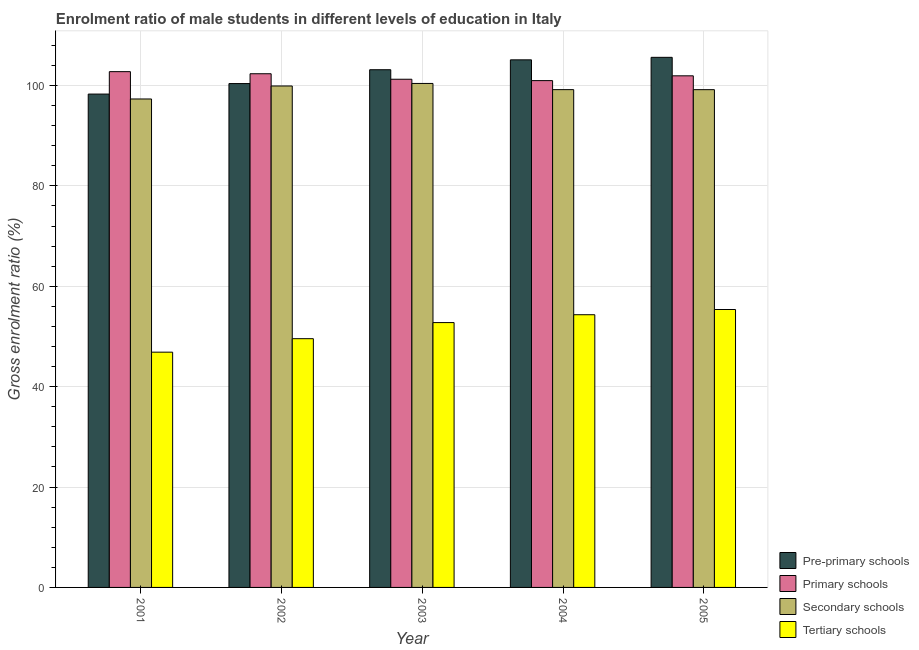How many groups of bars are there?
Provide a succinct answer. 5. How many bars are there on the 1st tick from the left?
Offer a very short reply. 4. What is the label of the 1st group of bars from the left?
Offer a terse response. 2001. What is the gross enrolment ratio(female) in primary schools in 2001?
Give a very brief answer. 102.76. Across all years, what is the maximum gross enrolment ratio(female) in tertiary schools?
Give a very brief answer. 55.37. Across all years, what is the minimum gross enrolment ratio(female) in secondary schools?
Give a very brief answer. 97.32. In which year was the gross enrolment ratio(female) in secondary schools maximum?
Your answer should be compact. 2003. What is the total gross enrolment ratio(female) in primary schools in the graph?
Your answer should be very brief. 509.27. What is the difference between the gross enrolment ratio(female) in pre-primary schools in 2002 and that in 2004?
Keep it short and to the point. -4.73. What is the difference between the gross enrolment ratio(female) in pre-primary schools in 2004 and the gross enrolment ratio(female) in primary schools in 2002?
Your response must be concise. 4.73. What is the average gross enrolment ratio(female) in primary schools per year?
Your answer should be very brief. 101.85. In how many years, is the gross enrolment ratio(female) in secondary schools greater than 64 %?
Provide a succinct answer. 5. What is the ratio of the gross enrolment ratio(female) in primary schools in 2001 to that in 2004?
Make the answer very short. 1.02. Is the gross enrolment ratio(female) in secondary schools in 2003 less than that in 2004?
Provide a short and direct response. No. Is the difference between the gross enrolment ratio(female) in tertiary schools in 2003 and 2004 greater than the difference between the gross enrolment ratio(female) in pre-primary schools in 2003 and 2004?
Provide a succinct answer. No. What is the difference between the highest and the second highest gross enrolment ratio(female) in primary schools?
Your answer should be compact. 0.42. What is the difference between the highest and the lowest gross enrolment ratio(female) in tertiary schools?
Give a very brief answer. 8.5. Is the sum of the gross enrolment ratio(female) in pre-primary schools in 2003 and 2004 greater than the maximum gross enrolment ratio(female) in primary schools across all years?
Ensure brevity in your answer.  Yes. What does the 1st bar from the left in 2003 represents?
Ensure brevity in your answer.  Pre-primary schools. What does the 3rd bar from the right in 2003 represents?
Ensure brevity in your answer.  Primary schools. Is it the case that in every year, the sum of the gross enrolment ratio(female) in pre-primary schools and gross enrolment ratio(female) in primary schools is greater than the gross enrolment ratio(female) in secondary schools?
Give a very brief answer. Yes. How many years are there in the graph?
Provide a short and direct response. 5. Does the graph contain grids?
Your answer should be very brief. Yes. How many legend labels are there?
Ensure brevity in your answer.  4. What is the title of the graph?
Your response must be concise. Enrolment ratio of male students in different levels of education in Italy. What is the label or title of the Y-axis?
Your answer should be compact. Gross enrolment ratio (%). What is the Gross enrolment ratio (%) of Pre-primary schools in 2001?
Your response must be concise. 98.29. What is the Gross enrolment ratio (%) of Primary schools in 2001?
Offer a very short reply. 102.76. What is the Gross enrolment ratio (%) in Secondary schools in 2001?
Make the answer very short. 97.32. What is the Gross enrolment ratio (%) of Tertiary schools in 2001?
Keep it short and to the point. 46.87. What is the Gross enrolment ratio (%) in Pre-primary schools in 2002?
Your response must be concise. 100.39. What is the Gross enrolment ratio (%) in Primary schools in 2002?
Provide a succinct answer. 102.34. What is the Gross enrolment ratio (%) in Secondary schools in 2002?
Offer a very short reply. 99.91. What is the Gross enrolment ratio (%) of Tertiary schools in 2002?
Ensure brevity in your answer.  49.56. What is the Gross enrolment ratio (%) in Pre-primary schools in 2003?
Offer a very short reply. 103.15. What is the Gross enrolment ratio (%) in Primary schools in 2003?
Offer a very short reply. 101.25. What is the Gross enrolment ratio (%) of Secondary schools in 2003?
Give a very brief answer. 100.41. What is the Gross enrolment ratio (%) of Tertiary schools in 2003?
Provide a succinct answer. 52.77. What is the Gross enrolment ratio (%) of Pre-primary schools in 2004?
Your answer should be compact. 105.12. What is the Gross enrolment ratio (%) in Primary schools in 2004?
Keep it short and to the point. 100.98. What is the Gross enrolment ratio (%) of Secondary schools in 2004?
Your response must be concise. 99.18. What is the Gross enrolment ratio (%) in Tertiary schools in 2004?
Your answer should be very brief. 54.33. What is the Gross enrolment ratio (%) in Pre-primary schools in 2005?
Offer a very short reply. 105.62. What is the Gross enrolment ratio (%) in Primary schools in 2005?
Offer a terse response. 101.93. What is the Gross enrolment ratio (%) in Secondary schools in 2005?
Offer a very short reply. 99.17. What is the Gross enrolment ratio (%) in Tertiary schools in 2005?
Offer a very short reply. 55.37. Across all years, what is the maximum Gross enrolment ratio (%) of Pre-primary schools?
Keep it short and to the point. 105.62. Across all years, what is the maximum Gross enrolment ratio (%) in Primary schools?
Your response must be concise. 102.76. Across all years, what is the maximum Gross enrolment ratio (%) in Secondary schools?
Ensure brevity in your answer.  100.41. Across all years, what is the maximum Gross enrolment ratio (%) in Tertiary schools?
Provide a succinct answer. 55.37. Across all years, what is the minimum Gross enrolment ratio (%) in Pre-primary schools?
Provide a short and direct response. 98.29. Across all years, what is the minimum Gross enrolment ratio (%) of Primary schools?
Ensure brevity in your answer.  100.98. Across all years, what is the minimum Gross enrolment ratio (%) in Secondary schools?
Provide a succinct answer. 97.32. Across all years, what is the minimum Gross enrolment ratio (%) of Tertiary schools?
Your response must be concise. 46.87. What is the total Gross enrolment ratio (%) in Pre-primary schools in the graph?
Your answer should be compact. 512.56. What is the total Gross enrolment ratio (%) of Primary schools in the graph?
Offer a terse response. 509.27. What is the total Gross enrolment ratio (%) of Secondary schools in the graph?
Your answer should be compact. 495.99. What is the total Gross enrolment ratio (%) of Tertiary schools in the graph?
Keep it short and to the point. 258.9. What is the difference between the Gross enrolment ratio (%) in Pre-primary schools in 2001 and that in 2002?
Offer a very short reply. -2.09. What is the difference between the Gross enrolment ratio (%) in Primary schools in 2001 and that in 2002?
Ensure brevity in your answer.  0.42. What is the difference between the Gross enrolment ratio (%) in Secondary schools in 2001 and that in 2002?
Ensure brevity in your answer.  -2.59. What is the difference between the Gross enrolment ratio (%) of Tertiary schools in 2001 and that in 2002?
Ensure brevity in your answer.  -2.69. What is the difference between the Gross enrolment ratio (%) in Pre-primary schools in 2001 and that in 2003?
Your answer should be compact. -4.85. What is the difference between the Gross enrolment ratio (%) of Primary schools in 2001 and that in 2003?
Offer a very short reply. 1.51. What is the difference between the Gross enrolment ratio (%) of Secondary schools in 2001 and that in 2003?
Provide a succinct answer. -3.09. What is the difference between the Gross enrolment ratio (%) of Tertiary schools in 2001 and that in 2003?
Your response must be concise. -5.89. What is the difference between the Gross enrolment ratio (%) in Pre-primary schools in 2001 and that in 2004?
Ensure brevity in your answer.  -6.82. What is the difference between the Gross enrolment ratio (%) in Primary schools in 2001 and that in 2004?
Provide a succinct answer. 1.79. What is the difference between the Gross enrolment ratio (%) in Secondary schools in 2001 and that in 2004?
Your response must be concise. -1.86. What is the difference between the Gross enrolment ratio (%) in Tertiary schools in 2001 and that in 2004?
Keep it short and to the point. -7.46. What is the difference between the Gross enrolment ratio (%) of Pre-primary schools in 2001 and that in 2005?
Your answer should be very brief. -7.32. What is the difference between the Gross enrolment ratio (%) in Primary schools in 2001 and that in 2005?
Your answer should be compact. 0.83. What is the difference between the Gross enrolment ratio (%) of Secondary schools in 2001 and that in 2005?
Offer a very short reply. -1.85. What is the difference between the Gross enrolment ratio (%) of Tertiary schools in 2001 and that in 2005?
Ensure brevity in your answer.  -8.5. What is the difference between the Gross enrolment ratio (%) in Pre-primary schools in 2002 and that in 2003?
Your answer should be compact. -2.76. What is the difference between the Gross enrolment ratio (%) in Primary schools in 2002 and that in 2003?
Your answer should be very brief. 1.1. What is the difference between the Gross enrolment ratio (%) in Secondary schools in 2002 and that in 2003?
Your answer should be very brief. -0.5. What is the difference between the Gross enrolment ratio (%) in Tertiary schools in 2002 and that in 2003?
Ensure brevity in your answer.  -3.21. What is the difference between the Gross enrolment ratio (%) in Pre-primary schools in 2002 and that in 2004?
Provide a short and direct response. -4.73. What is the difference between the Gross enrolment ratio (%) in Primary schools in 2002 and that in 2004?
Provide a succinct answer. 1.37. What is the difference between the Gross enrolment ratio (%) in Secondary schools in 2002 and that in 2004?
Offer a very short reply. 0.73. What is the difference between the Gross enrolment ratio (%) in Tertiary schools in 2002 and that in 2004?
Provide a succinct answer. -4.77. What is the difference between the Gross enrolment ratio (%) of Pre-primary schools in 2002 and that in 2005?
Your answer should be very brief. -5.23. What is the difference between the Gross enrolment ratio (%) in Primary schools in 2002 and that in 2005?
Offer a terse response. 0.41. What is the difference between the Gross enrolment ratio (%) in Secondary schools in 2002 and that in 2005?
Provide a succinct answer. 0.73. What is the difference between the Gross enrolment ratio (%) in Tertiary schools in 2002 and that in 2005?
Make the answer very short. -5.81. What is the difference between the Gross enrolment ratio (%) of Pre-primary schools in 2003 and that in 2004?
Offer a terse response. -1.97. What is the difference between the Gross enrolment ratio (%) of Primary schools in 2003 and that in 2004?
Provide a succinct answer. 0.27. What is the difference between the Gross enrolment ratio (%) of Secondary schools in 2003 and that in 2004?
Your answer should be very brief. 1.23. What is the difference between the Gross enrolment ratio (%) of Tertiary schools in 2003 and that in 2004?
Offer a very short reply. -1.56. What is the difference between the Gross enrolment ratio (%) in Pre-primary schools in 2003 and that in 2005?
Offer a very short reply. -2.47. What is the difference between the Gross enrolment ratio (%) in Primary schools in 2003 and that in 2005?
Offer a terse response. -0.68. What is the difference between the Gross enrolment ratio (%) of Secondary schools in 2003 and that in 2005?
Your answer should be very brief. 1.24. What is the difference between the Gross enrolment ratio (%) in Tertiary schools in 2003 and that in 2005?
Ensure brevity in your answer.  -2.6. What is the difference between the Gross enrolment ratio (%) of Pre-primary schools in 2004 and that in 2005?
Your answer should be compact. -0.5. What is the difference between the Gross enrolment ratio (%) of Primary schools in 2004 and that in 2005?
Provide a succinct answer. -0.96. What is the difference between the Gross enrolment ratio (%) of Secondary schools in 2004 and that in 2005?
Give a very brief answer. 0.01. What is the difference between the Gross enrolment ratio (%) of Tertiary schools in 2004 and that in 2005?
Ensure brevity in your answer.  -1.04. What is the difference between the Gross enrolment ratio (%) of Pre-primary schools in 2001 and the Gross enrolment ratio (%) of Primary schools in 2002?
Offer a terse response. -4.05. What is the difference between the Gross enrolment ratio (%) of Pre-primary schools in 2001 and the Gross enrolment ratio (%) of Secondary schools in 2002?
Offer a very short reply. -1.61. What is the difference between the Gross enrolment ratio (%) of Pre-primary schools in 2001 and the Gross enrolment ratio (%) of Tertiary schools in 2002?
Provide a short and direct response. 48.73. What is the difference between the Gross enrolment ratio (%) of Primary schools in 2001 and the Gross enrolment ratio (%) of Secondary schools in 2002?
Your answer should be compact. 2.86. What is the difference between the Gross enrolment ratio (%) of Primary schools in 2001 and the Gross enrolment ratio (%) of Tertiary schools in 2002?
Your answer should be very brief. 53.2. What is the difference between the Gross enrolment ratio (%) of Secondary schools in 2001 and the Gross enrolment ratio (%) of Tertiary schools in 2002?
Provide a short and direct response. 47.76. What is the difference between the Gross enrolment ratio (%) in Pre-primary schools in 2001 and the Gross enrolment ratio (%) in Primary schools in 2003?
Ensure brevity in your answer.  -2.96. What is the difference between the Gross enrolment ratio (%) in Pre-primary schools in 2001 and the Gross enrolment ratio (%) in Secondary schools in 2003?
Offer a very short reply. -2.12. What is the difference between the Gross enrolment ratio (%) in Pre-primary schools in 2001 and the Gross enrolment ratio (%) in Tertiary schools in 2003?
Make the answer very short. 45.53. What is the difference between the Gross enrolment ratio (%) of Primary schools in 2001 and the Gross enrolment ratio (%) of Secondary schools in 2003?
Keep it short and to the point. 2.35. What is the difference between the Gross enrolment ratio (%) of Primary schools in 2001 and the Gross enrolment ratio (%) of Tertiary schools in 2003?
Your answer should be compact. 50. What is the difference between the Gross enrolment ratio (%) of Secondary schools in 2001 and the Gross enrolment ratio (%) of Tertiary schools in 2003?
Offer a very short reply. 44.55. What is the difference between the Gross enrolment ratio (%) of Pre-primary schools in 2001 and the Gross enrolment ratio (%) of Primary schools in 2004?
Keep it short and to the point. -2.68. What is the difference between the Gross enrolment ratio (%) of Pre-primary schools in 2001 and the Gross enrolment ratio (%) of Secondary schools in 2004?
Your answer should be very brief. -0.88. What is the difference between the Gross enrolment ratio (%) of Pre-primary schools in 2001 and the Gross enrolment ratio (%) of Tertiary schools in 2004?
Provide a short and direct response. 43.96. What is the difference between the Gross enrolment ratio (%) of Primary schools in 2001 and the Gross enrolment ratio (%) of Secondary schools in 2004?
Your answer should be very brief. 3.59. What is the difference between the Gross enrolment ratio (%) of Primary schools in 2001 and the Gross enrolment ratio (%) of Tertiary schools in 2004?
Provide a succinct answer. 48.43. What is the difference between the Gross enrolment ratio (%) of Secondary schools in 2001 and the Gross enrolment ratio (%) of Tertiary schools in 2004?
Give a very brief answer. 42.99. What is the difference between the Gross enrolment ratio (%) of Pre-primary schools in 2001 and the Gross enrolment ratio (%) of Primary schools in 2005?
Your answer should be very brief. -3.64. What is the difference between the Gross enrolment ratio (%) in Pre-primary schools in 2001 and the Gross enrolment ratio (%) in Secondary schools in 2005?
Offer a very short reply. -0.88. What is the difference between the Gross enrolment ratio (%) in Pre-primary schools in 2001 and the Gross enrolment ratio (%) in Tertiary schools in 2005?
Provide a succinct answer. 42.92. What is the difference between the Gross enrolment ratio (%) of Primary schools in 2001 and the Gross enrolment ratio (%) of Secondary schools in 2005?
Ensure brevity in your answer.  3.59. What is the difference between the Gross enrolment ratio (%) in Primary schools in 2001 and the Gross enrolment ratio (%) in Tertiary schools in 2005?
Offer a terse response. 47.39. What is the difference between the Gross enrolment ratio (%) in Secondary schools in 2001 and the Gross enrolment ratio (%) in Tertiary schools in 2005?
Offer a very short reply. 41.95. What is the difference between the Gross enrolment ratio (%) of Pre-primary schools in 2002 and the Gross enrolment ratio (%) of Primary schools in 2003?
Offer a very short reply. -0.86. What is the difference between the Gross enrolment ratio (%) in Pre-primary schools in 2002 and the Gross enrolment ratio (%) in Secondary schools in 2003?
Provide a succinct answer. -0.02. What is the difference between the Gross enrolment ratio (%) of Pre-primary schools in 2002 and the Gross enrolment ratio (%) of Tertiary schools in 2003?
Provide a succinct answer. 47.62. What is the difference between the Gross enrolment ratio (%) in Primary schools in 2002 and the Gross enrolment ratio (%) in Secondary schools in 2003?
Your answer should be very brief. 1.93. What is the difference between the Gross enrolment ratio (%) of Primary schools in 2002 and the Gross enrolment ratio (%) of Tertiary schools in 2003?
Offer a very short reply. 49.58. What is the difference between the Gross enrolment ratio (%) in Secondary schools in 2002 and the Gross enrolment ratio (%) in Tertiary schools in 2003?
Keep it short and to the point. 47.14. What is the difference between the Gross enrolment ratio (%) of Pre-primary schools in 2002 and the Gross enrolment ratio (%) of Primary schools in 2004?
Give a very brief answer. -0.59. What is the difference between the Gross enrolment ratio (%) in Pre-primary schools in 2002 and the Gross enrolment ratio (%) in Secondary schools in 2004?
Offer a very short reply. 1.21. What is the difference between the Gross enrolment ratio (%) of Pre-primary schools in 2002 and the Gross enrolment ratio (%) of Tertiary schools in 2004?
Keep it short and to the point. 46.06. What is the difference between the Gross enrolment ratio (%) of Primary schools in 2002 and the Gross enrolment ratio (%) of Secondary schools in 2004?
Your response must be concise. 3.17. What is the difference between the Gross enrolment ratio (%) in Primary schools in 2002 and the Gross enrolment ratio (%) in Tertiary schools in 2004?
Your response must be concise. 48.01. What is the difference between the Gross enrolment ratio (%) in Secondary schools in 2002 and the Gross enrolment ratio (%) in Tertiary schools in 2004?
Make the answer very short. 45.57. What is the difference between the Gross enrolment ratio (%) in Pre-primary schools in 2002 and the Gross enrolment ratio (%) in Primary schools in 2005?
Provide a short and direct response. -1.54. What is the difference between the Gross enrolment ratio (%) in Pre-primary schools in 2002 and the Gross enrolment ratio (%) in Secondary schools in 2005?
Ensure brevity in your answer.  1.22. What is the difference between the Gross enrolment ratio (%) of Pre-primary schools in 2002 and the Gross enrolment ratio (%) of Tertiary schools in 2005?
Give a very brief answer. 45.02. What is the difference between the Gross enrolment ratio (%) of Primary schools in 2002 and the Gross enrolment ratio (%) of Secondary schools in 2005?
Provide a succinct answer. 3.17. What is the difference between the Gross enrolment ratio (%) in Primary schools in 2002 and the Gross enrolment ratio (%) in Tertiary schools in 2005?
Offer a terse response. 46.97. What is the difference between the Gross enrolment ratio (%) in Secondary schools in 2002 and the Gross enrolment ratio (%) in Tertiary schools in 2005?
Offer a very short reply. 44.54. What is the difference between the Gross enrolment ratio (%) in Pre-primary schools in 2003 and the Gross enrolment ratio (%) in Primary schools in 2004?
Offer a terse response. 2.17. What is the difference between the Gross enrolment ratio (%) in Pre-primary schools in 2003 and the Gross enrolment ratio (%) in Secondary schools in 2004?
Your answer should be compact. 3.97. What is the difference between the Gross enrolment ratio (%) in Pre-primary schools in 2003 and the Gross enrolment ratio (%) in Tertiary schools in 2004?
Your answer should be very brief. 48.81. What is the difference between the Gross enrolment ratio (%) of Primary schools in 2003 and the Gross enrolment ratio (%) of Secondary schools in 2004?
Offer a very short reply. 2.07. What is the difference between the Gross enrolment ratio (%) of Primary schools in 2003 and the Gross enrolment ratio (%) of Tertiary schools in 2004?
Offer a very short reply. 46.92. What is the difference between the Gross enrolment ratio (%) in Secondary schools in 2003 and the Gross enrolment ratio (%) in Tertiary schools in 2004?
Offer a terse response. 46.08. What is the difference between the Gross enrolment ratio (%) of Pre-primary schools in 2003 and the Gross enrolment ratio (%) of Primary schools in 2005?
Offer a very short reply. 1.21. What is the difference between the Gross enrolment ratio (%) in Pre-primary schools in 2003 and the Gross enrolment ratio (%) in Secondary schools in 2005?
Ensure brevity in your answer.  3.97. What is the difference between the Gross enrolment ratio (%) in Pre-primary schools in 2003 and the Gross enrolment ratio (%) in Tertiary schools in 2005?
Keep it short and to the point. 47.78. What is the difference between the Gross enrolment ratio (%) of Primary schools in 2003 and the Gross enrolment ratio (%) of Secondary schools in 2005?
Make the answer very short. 2.08. What is the difference between the Gross enrolment ratio (%) in Primary schools in 2003 and the Gross enrolment ratio (%) in Tertiary schools in 2005?
Your answer should be very brief. 45.88. What is the difference between the Gross enrolment ratio (%) of Secondary schools in 2003 and the Gross enrolment ratio (%) of Tertiary schools in 2005?
Your answer should be compact. 45.04. What is the difference between the Gross enrolment ratio (%) of Pre-primary schools in 2004 and the Gross enrolment ratio (%) of Primary schools in 2005?
Your answer should be compact. 3.18. What is the difference between the Gross enrolment ratio (%) in Pre-primary schools in 2004 and the Gross enrolment ratio (%) in Secondary schools in 2005?
Your answer should be very brief. 5.94. What is the difference between the Gross enrolment ratio (%) in Pre-primary schools in 2004 and the Gross enrolment ratio (%) in Tertiary schools in 2005?
Give a very brief answer. 49.74. What is the difference between the Gross enrolment ratio (%) in Primary schools in 2004 and the Gross enrolment ratio (%) in Secondary schools in 2005?
Provide a succinct answer. 1.8. What is the difference between the Gross enrolment ratio (%) in Primary schools in 2004 and the Gross enrolment ratio (%) in Tertiary schools in 2005?
Provide a succinct answer. 45.61. What is the difference between the Gross enrolment ratio (%) in Secondary schools in 2004 and the Gross enrolment ratio (%) in Tertiary schools in 2005?
Provide a succinct answer. 43.81. What is the average Gross enrolment ratio (%) of Pre-primary schools per year?
Offer a very short reply. 102.51. What is the average Gross enrolment ratio (%) in Primary schools per year?
Provide a short and direct response. 101.85. What is the average Gross enrolment ratio (%) of Secondary schools per year?
Ensure brevity in your answer.  99.2. What is the average Gross enrolment ratio (%) of Tertiary schools per year?
Offer a terse response. 51.78. In the year 2001, what is the difference between the Gross enrolment ratio (%) in Pre-primary schools and Gross enrolment ratio (%) in Primary schools?
Ensure brevity in your answer.  -4.47. In the year 2001, what is the difference between the Gross enrolment ratio (%) in Pre-primary schools and Gross enrolment ratio (%) in Secondary schools?
Ensure brevity in your answer.  0.98. In the year 2001, what is the difference between the Gross enrolment ratio (%) in Pre-primary schools and Gross enrolment ratio (%) in Tertiary schools?
Provide a short and direct response. 51.42. In the year 2001, what is the difference between the Gross enrolment ratio (%) of Primary schools and Gross enrolment ratio (%) of Secondary schools?
Offer a very short reply. 5.45. In the year 2001, what is the difference between the Gross enrolment ratio (%) of Primary schools and Gross enrolment ratio (%) of Tertiary schools?
Keep it short and to the point. 55.89. In the year 2001, what is the difference between the Gross enrolment ratio (%) of Secondary schools and Gross enrolment ratio (%) of Tertiary schools?
Give a very brief answer. 50.45. In the year 2002, what is the difference between the Gross enrolment ratio (%) of Pre-primary schools and Gross enrolment ratio (%) of Primary schools?
Offer a terse response. -1.96. In the year 2002, what is the difference between the Gross enrolment ratio (%) of Pre-primary schools and Gross enrolment ratio (%) of Secondary schools?
Offer a very short reply. 0.48. In the year 2002, what is the difference between the Gross enrolment ratio (%) of Pre-primary schools and Gross enrolment ratio (%) of Tertiary schools?
Your answer should be compact. 50.83. In the year 2002, what is the difference between the Gross enrolment ratio (%) of Primary schools and Gross enrolment ratio (%) of Secondary schools?
Provide a succinct answer. 2.44. In the year 2002, what is the difference between the Gross enrolment ratio (%) in Primary schools and Gross enrolment ratio (%) in Tertiary schools?
Give a very brief answer. 52.78. In the year 2002, what is the difference between the Gross enrolment ratio (%) of Secondary schools and Gross enrolment ratio (%) of Tertiary schools?
Offer a very short reply. 50.35. In the year 2003, what is the difference between the Gross enrolment ratio (%) of Pre-primary schools and Gross enrolment ratio (%) of Primary schools?
Ensure brevity in your answer.  1.9. In the year 2003, what is the difference between the Gross enrolment ratio (%) in Pre-primary schools and Gross enrolment ratio (%) in Secondary schools?
Keep it short and to the point. 2.74. In the year 2003, what is the difference between the Gross enrolment ratio (%) in Pre-primary schools and Gross enrolment ratio (%) in Tertiary schools?
Provide a short and direct response. 50.38. In the year 2003, what is the difference between the Gross enrolment ratio (%) in Primary schools and Gross enrolment ratio (%) in Secondary schools?
Your response must be concise. 0.84. In the year 2003, what is the difference between the Gross enrolment ratio (%) in Primary schools and Gross enrolment ratio (%) in Tertiary schools?
Make the answer very short. 48.48. In the year 2003, what is the difference between the Gross enrolment ratio (%) in Secondary schools and Gross enrolment ratio (%) in Tertiary schools?
Provide a short and direct response. 47.64. In the year 2004, what is the difference between the Gross enrolment ratio (%) of Pre-primary schools and Gross enrolment ratio (%) of Primary schools?
Give a very brief answer. 4.14. In the year 2004, what is the difference between the Gross enrolment ratio (%) in Pre-primary schools and Gross enrolment ratio (%) in Secondary schools?
Your answer should be very brief. 5.94. In the year 2004, what is the difference between the Gross enrolment ratio (%) in Pre-primary schools and Gross enrolment ratio (%) in Tertiary schools?
Ensure brevity in your answer.  50.78. In the year 2004, what is the difference between the Gross enrolment ratio (%) in Primary schools and Gross enrolment ratio (%) in Secondary schools?
Your response must be concise. 1.8. In the year 2004, what is the difference between the Gross enrolment ratio (%) of Primary schools and Gross enrolment ratio (%) of Tertiary schools?
Provide a succinct answer. 46.64. In the year 2004, what is the difference between the Gross enrolment ratio (%) of Secondary schools and Gross enrolment ratio (%) of Tertiary schools?
Offer a very short reply. 44.85. In the year 2005, what is the difference between the Gross enrolment ratio (%) in Pre-primary schools and Gross enrolment ratio (%) in Primary schools?
Ensure brevity in your answer.  3.68. In the year 2005, what is the difference between the Gross enrolment ratio (%) in Pre-primary schools and Gross enrolment ratio (%) in Secondary schools?
Give a very brief answer. 6.44. In the year 2005, what is the difference between the Gross enrolment ratio (%) of Pre-primary schools and Gross enrolment ratio (%) of Tertiary schools?
Make the answer very short. 50.24. In the year 2005, what is the difference between the Gross enrolment ratio (%) in Primary schools and Gross enrolment ratio (%) in Secondary schools?
Provide a succinct answer. 2.76. In the year 2005, what is the difference between the Gross enrolment ratio (%) of Primary schools and Gross enrolment ratio (%) of Tertiary schools?
Your answer should be compact. 46.56. In the year 2005, what is the difference between the Gross enrolment ratio (%) in Secondary schools and Gross enrolment ratio (%) in Tertiary schools?
Keep it short and to the point. 43.8. What is the ratio of the Gross enrolment ratio (%) of Pre-primary schools in 2001 to that in 2002?
Offer a terse response. 0.98. What is the ratio of the Gross enrolment ratio (%) in Primary schools in 2001 to that in 2002?
Offer a very short reply. 1. What is the ratio of the Gross enrolment ratio (%) in Secondary schools in 2001 to that in 2002?
Your response must be concise. 0.97. What is the ratio of the Gross enrolment ratio (%) of Tertiary schools in 2001 to that in 2002?
Your answer should be compact. 0.95. What is the ratio of the Gross enrolment ratio (%) in Pre-primary schools in 2001 to that in 2003?
Make the answer very short. 0.95. What is the ratio of the Gross enrolment ratio (%) in Secondary schools in 2001 to that in 2003?
Give a very brief answer. 0.97. What is the ratio of the Gross enrolment ratio (%) in Tertiary schools in 2001 to that in 2003?
Give a very brief answer. 0.89. What is the ratio of the Gross enrolment ratio (%) in Pre-primary schools in 2001 to that in 2004?
Provide a succinct answer. 0.94. What is the ratio of the Gross enrolment ratio (%) of Primary schools in 2001 to that in 2004?
Provide a succinct answer. 1.02. What is the ratio of the Gross enrolment ratio (%) of Secondary schools in 2001 to that in 2004?
Offer a terse response. 0.98. What is the ratio of the Gross enrolment ratio (%) in Tertiary schools in 2001 to that in 2004?
Your response must be concise. 0.86. What is the ratio of the Gross enrolment ratio (%) in Pre-primary schools in 2001 to that in 2005?
Provide a short and direct response. 0.93. What is the ratio of the Gross enrolment ratio (%) in Primary schools in 2001 to that in 2005?
Offer a terse response. 1.01. What is the ratio of the Gross enrolment ratio (%) in Secondary schools in 2001 to that in 2005?
Provide a short and direct response. 0.98. What is the ratio of the Gross enrolment ratio (%) in Tertiary schools in 2001 to that in 2005?
Make the answer very short. 0.85. What is the ratio of the Gross enrolment ratio (%) of Pre-primary schools in 2002 to that in 2003?
Your answer should be very brief. 0.97. What is the ratio of the Gross enrolment ratio (%) of Primary schools in 2002 to that in 2003?
Ensure brevity in your answer.  1.01. What is the ratio of the Gross enrolment ratio (%) of Tertiary schools in 2002 to that in 2003?
Give a very brief answer. 0.94. What is the ratio of the Gross enrolment ratio (%) of Pre-primary schools in 2002 to that in 2004?
Offer a terse response. 0.95. What is the ratio of the Gross enrolment ratio (%) in Primary schools in 2002 to that in 2004?
Give a very brief answer. 1.01. What is the ratio of the Gross enrolment ratio (%) in Secondary schools in 2002 to that in 2004?
Keep it short and to the point. 1.01. What is the ratio of the Gross enrolment ratio (%) in Tertiary schools in 2002 to that in 2004?
Make the answer very short. 0.91. What is the ratio of the Gross enrolment ratio (%) of Pre-primary schools in 2002 to that in 2005?
Provide a succinct answer. 0.95. What is the ratio of the Gross enrolment ratio (%) in Secondary schools in 2002 to that in 2005?
Your answer should be compact. 1.01. What is the ratio of the Gross enrolment ratio (%) of Tertiary schools in 2002 to that in 2005?
Offer a terse response. 0.9. What is the ratio of the Gross enrolment ratio (%) of Pre-primary schools in 2003 to that in 2004?
Keep it short and to the point. 0.98. What is the ratio of the Gross enrolment ratio (%) in Primary schools in 2003 to that in 2004?
Your response must be concise. 1. What is the ratio of the Gross enrolment ratio (%) in Secondary schools in 2003 to that in 2004?
Make the answer very short. 1.01. What is the ratio of the Gross enrolment ratio (%) of Tertiary schools in 2003 to that in 2004?
Keep it short and to the point. 0.97. What is the ratio of the Gross enrolment ratio (%) of Pre-primary schools in 2003 to that in 2005?
Keep it short and to the point. 0.98. What is the ratio of the Gross enrolment ratio (%) of Primary schools in 2003 to that in 2005?
Keep it short and to the point. 0.99. What is the ratio of the Gross enrolment ratio (%) of Secondary schools in 2003 to that in 2005?
Ensure brevity in your answer.  1.01. What is the ratio of the Gross enrolment ratio (%) of Tertiary schools in 2003 to that in 2005?
Keep it short and to the point. 0.95. What is the ratio of the Gross enrolment ratio (%) of Primary schools in 2004 to that in 2005?
Give a very brief answer. 0.99. What is the ratio of the Gross enrolment ratio (%) of Secondary schools in 2004 to that in 2005?
Provide a short and direct response. 1. What is the ratio of the Gross enrolment ratio (%) of Tertiary schools in 2004 to that in 2005?
Make the answer very short. 0.98. What is the difference between the highest and the second highest Gross enrolment ratio (%) in Pre-primary schools?
Your answer should be very brief. 0.5. What is the difference between the highest and the second highest Gross enrolment ratio (%) of Primary schools?
Your response must be concise. 0.42. What is the difference between the highest and the second highest Gross enrolment ratio (%) of Secondary schools?
Provide a succinct answer. 0.5. What is the difference between the highest and the second highest Gross enrolment ratio (%) in Tertiary schools?
Offer a terse response. 1.04. What is the difference between the highest and the lowest Gross enrolment ratio (%) in Pre-primary schools?
Offer a very short reply. 7.32. What is the difference between the highest and the lowest Gross enrolment ratio (%) of Primary schools?
Your answer should be compact. 1.79. What is the difference between the highest and the lowest Gross enrolment ratio (%) in Secondary schools?
Ensure brevity in your answer.  3.09. What is the difference between the highest and the lowest Gross enrolment ratio (%) in Tertiary schools?
Give a very brief answer. 8.5. 